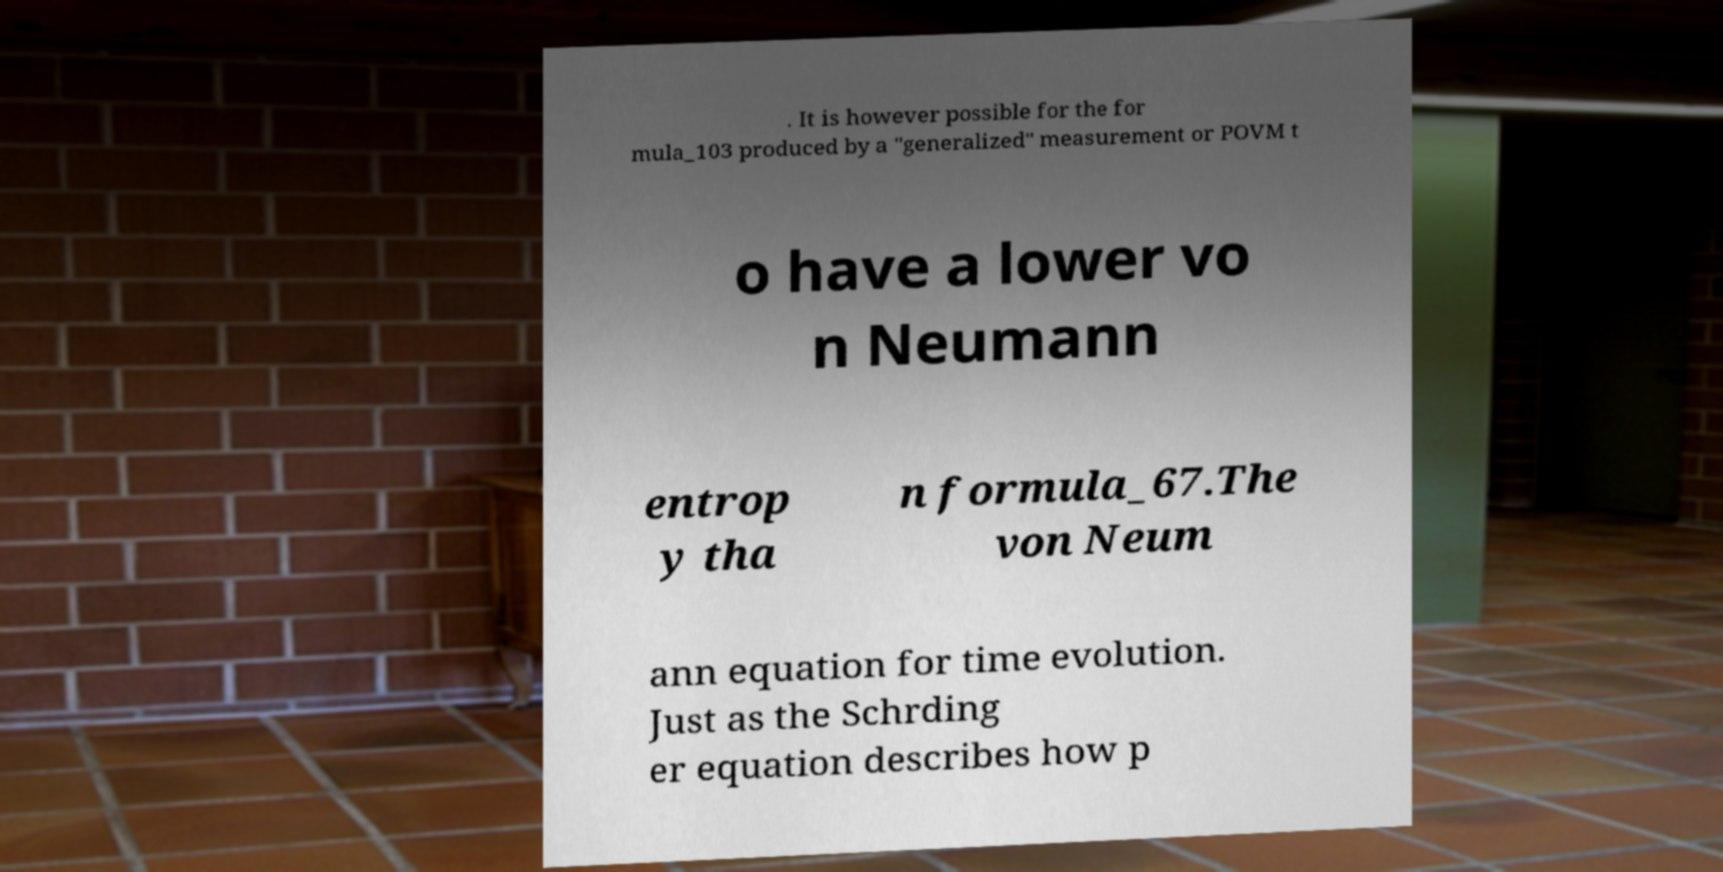Can you accurately transcribe the text from the provided image for me? . It is however possible for the for mula_103 produced by a "generalized" measurement or POVM t o have a lower vo n Neumann entrop y tha n formula_67.The von Neum ann equation for time evolution. Just as the Schrding er equation describes how p 